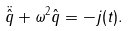<formula> <loc_0><loc_0><loc_500><loc_500>\ddot { \hat { q } } + \omega ^ { 2 } \hat { q } = - j ( t ) .</formula> 